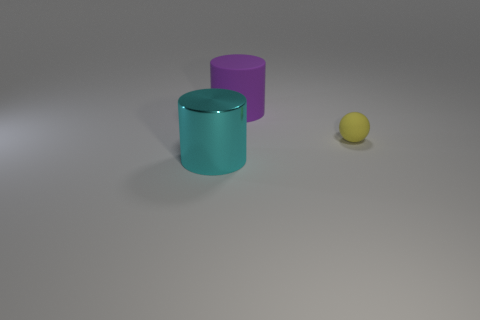Add 1 red cylinders. How many objects exist? 4 Subtract all cylinders. How many objects are left? 1 Subtract all large blue shiny cubes. Subtract all large objects. How many objects are left? 1 Add 2 big shiny objects. How many big shiny objects are left? 3 Add 1 big purple objects. How many big purple objects exist? 2 Subtract 0 green blocks. How many objects are left? 3 